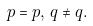<formula> <loc_0><loc_0><loc_500><loc_500>p = p , \, q \neq q .</formula> 